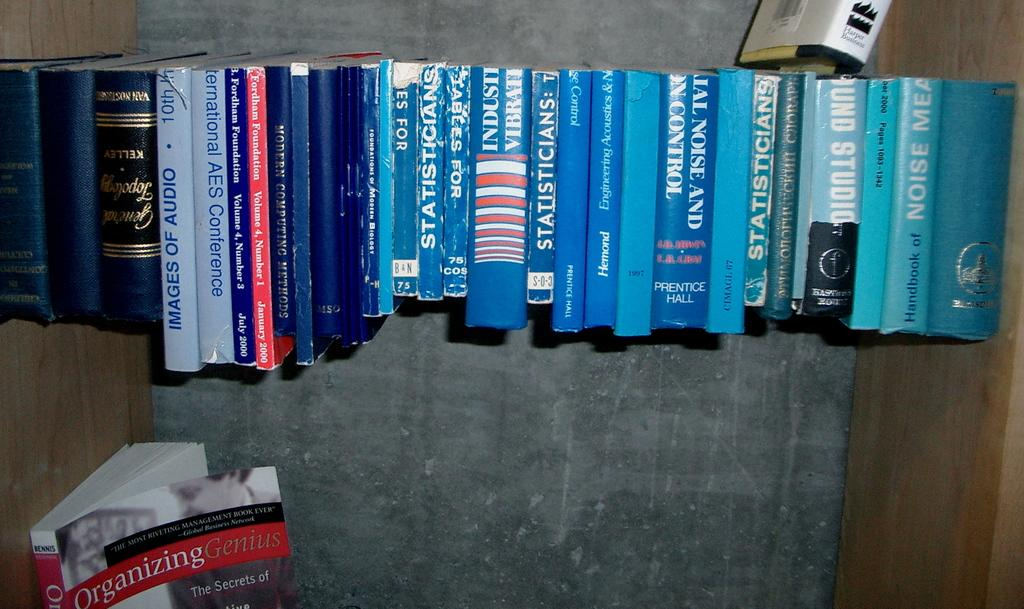<image>
Render a clear and concise summary of the photo. Books that are lined up together like statisticians 